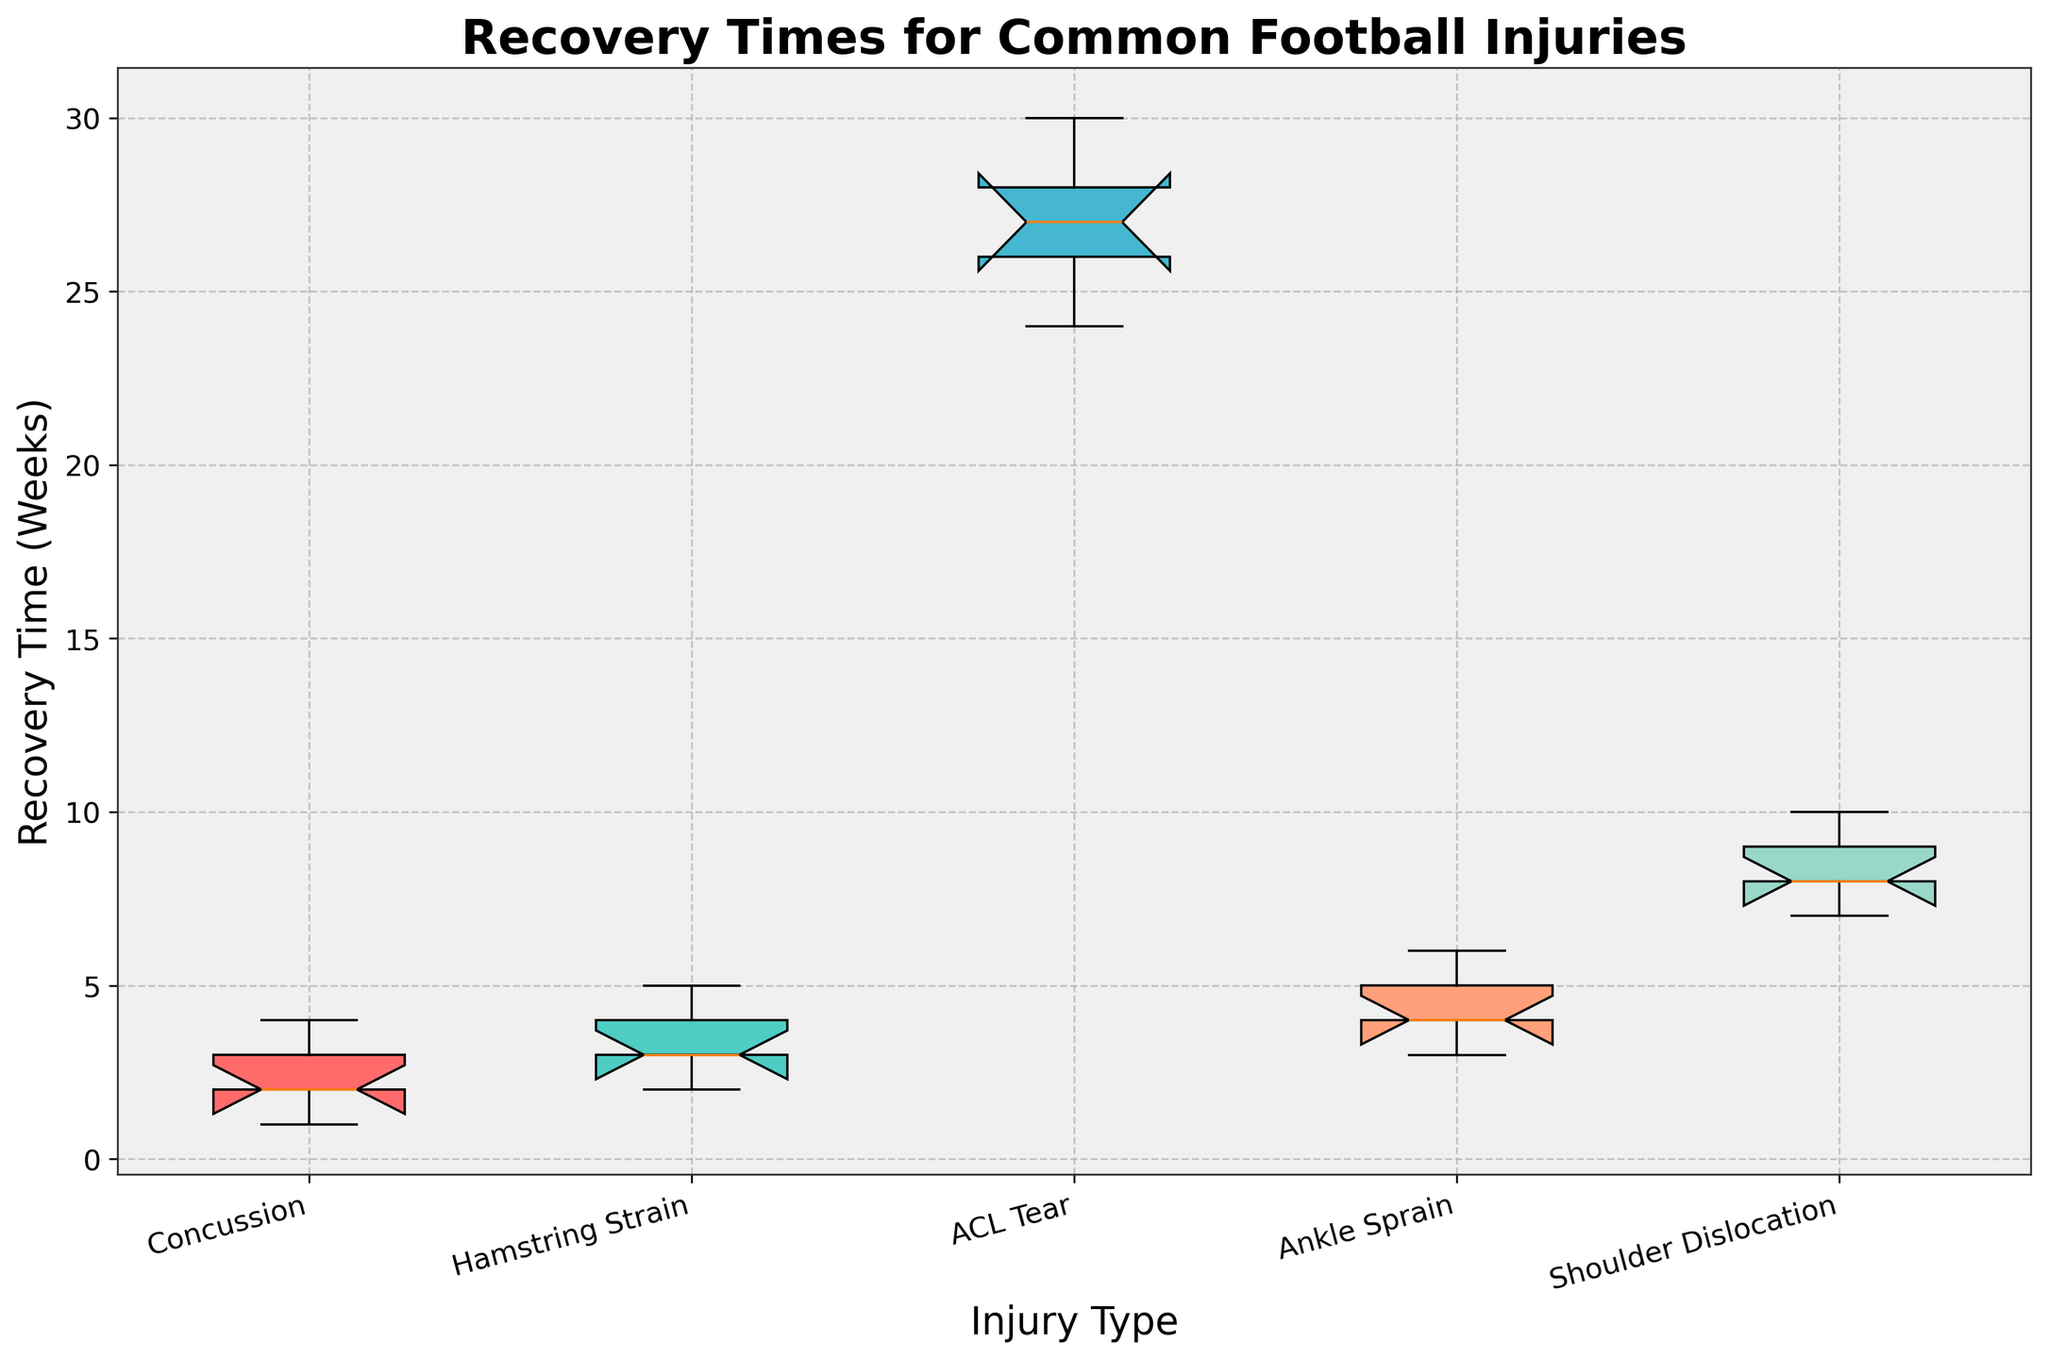Which injury has the longest median recovery time? The median recovery time is visually represented by the line inside the box. For ACL Tear, the line is higher than for the other injuries.
Answer: ACL Tear What's the shortest recovery time for a concussion? The bottom of the box plot whisker represents the minimum recovery time for each injury. For a concussion, the whisker reaches down to 1 week.
Answer: 1 week How many different types of injuries are shown in the plot? The x-axis labels indicate the different types of injuries. Counting these labels gives the number of injury types.
Answer: 5 Which injury type has the greatest variability in recovery times? Variability is represented by the length of the box and whiskers. ACL Tear has notably longer whiskers and box compared to others, showing greater variability.
Answer: ACL Tear Do any injuries show overlapping notches? Overlapping notches indicate that medians are not significantly different. By examining the notches across the injuries, no injuries have overlapping notches in this plot.
Answer: No What's the interquartile range (IQR) for ankle sprains? The IQR is the range between the top and bottom of the box. For ankle sprains, the box extends from 3 weeks to 5 weeks. The IQR is 5 - 3 = 2 weeks.
Answer: 2 weeks Which injury has the shortest median recovery time? The median recovery time is represented by the line inside the box. For concussions, this line is at 2 weeks, which is the shortest among the injuries.
Answer: Concussion What color represents shoulder dislocations in the plot? Each injury type is represented by a different colored box. The box for shoulder dislocations is colored with a light mint green shade.
Answer: Mint green What's the maximum recovery time recorded for hamstring strains? The top of the box plot whisker represents the maximum value. For hamstring strains, the whisker reaches up to 5 weeks.
Answer: 5 weeks Comparing concussions and ankle sprains, which has a longer median recovery time? The median recovery time is shown by the line inside the box. For concussions, the median is at 2 weeks, and for ankle sprains, it's at 4 weeks.
Answer: Ankle sprains 